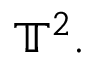<formula> <loc_0><loc_0><loc_500><loc_500>\mathbb { T } ^ { 2 } .</formula> 